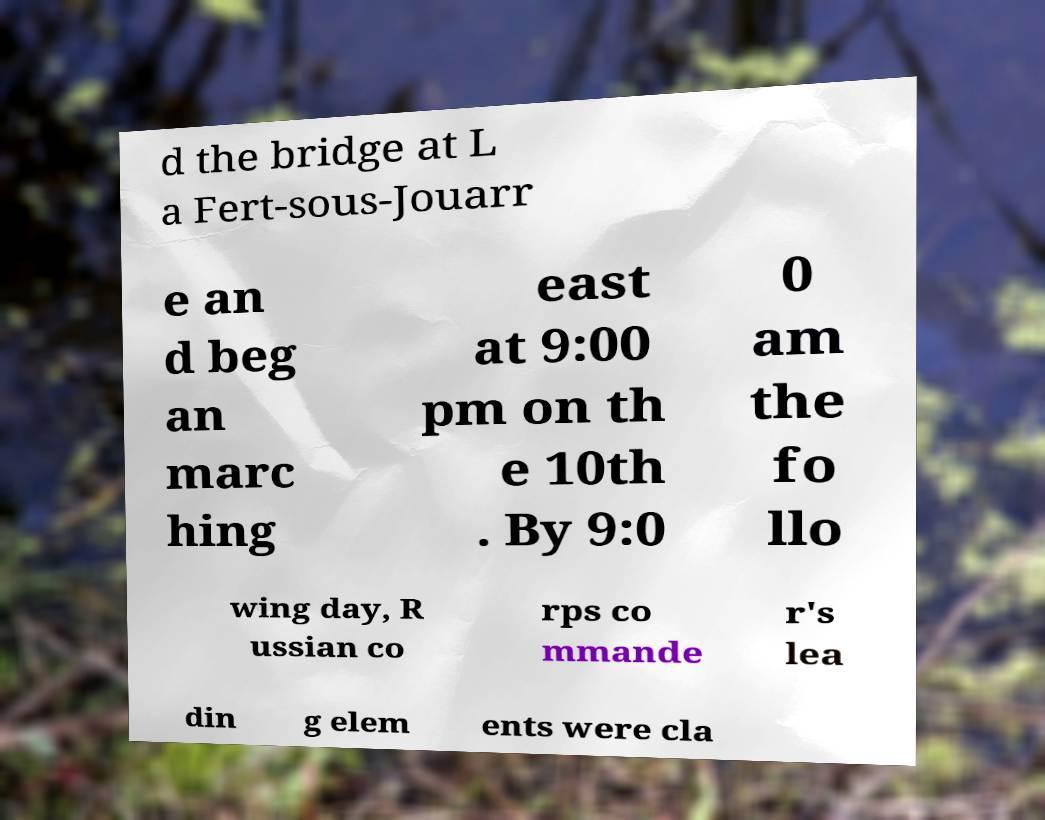Can you accurately transcribe the text from the provided image for me? d the bridge at L a Fert-sous-Jouarr e an d beg an marc hing east at 9:00 pm on th e 10th . By 9:0 0 am the fo llo wing day, R ussian co rps co mmande r's lea din g elem ents were cla 